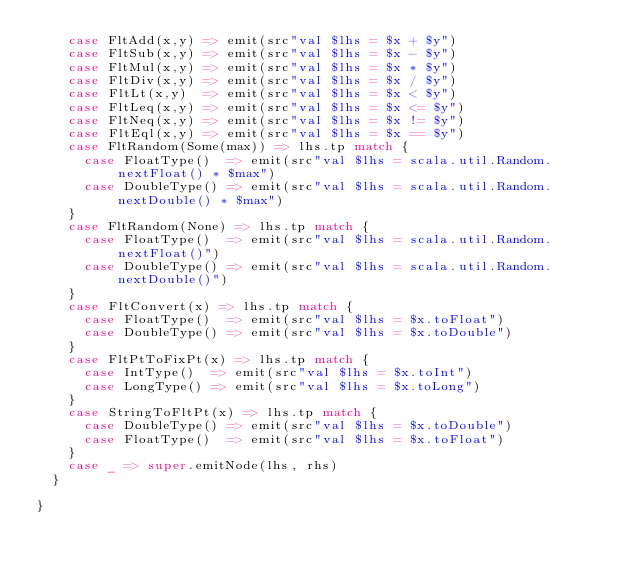<code> <loc_0><loc_0><loc_500><loc_500><_Scala_>    case FltAdd(x,y) => emit(src"val $lhs = $x + $y")
    case FltSub(x,y) => emit(src"val $lhs = $x - $y")
    case FltMul(x,y) => emit(src"val $lhs = $x * $y")
    case FltDiv(x,y) => emit(src"val $lhs = $x / $y")
    case FltLt(x,y)  => emit(src"val $lhs = $x < $y")
    case FltLeq(x,y) => emit(src"val $lhs = $x <= $y")
    case FltNeq(x,y) => emit(src"val $lhs = $x != $y")
    case FltEql(x,y) => emit(src"val $lhs = $x == $y")
    case FltRandom(Some(max)) => lhs.tp match {
      case FloatType()  => emit(src"val $lhs = scala.util.Random.nextFloat() * $max")
      case DoubleType() => emit(src"val $lhs = scala.util.Random.nextDouble() * $max")
    }
    case FltRandom(None) => lhs.tp match {
      case FloatType()  => emit(src"val $lhs = scala.util.Random.nextFloat()")
      case DoubleType() => emit(src"val $lhs = scala.util.Random.nextDouble()")
    }
    case FltConvert(x) => lhs.tp match {
      case FloatType()  => emit(src"val $lhs = $x.toFloat")
      case DoubleType() => emit(src"val $lhs = $x.toDouble")
    }
    case FltPtToFixPt(x) => lhs.tp match {
      case IntType()  => emit(src"val $lhs = $x.toInt")
      case LongType() => emit(src"val $lhs = $x.toLong")
    }
    case StringToFltPt(x) => lhs.tp match {
      case DoubleType() => emit(src"val $lhs = $x.toDouble")
      case FloatType()  => emit(src"val $lhs = $x.toFloat")
    }
    case _ => super.emitNode(lhs, rhs)
  }

}
</code> 